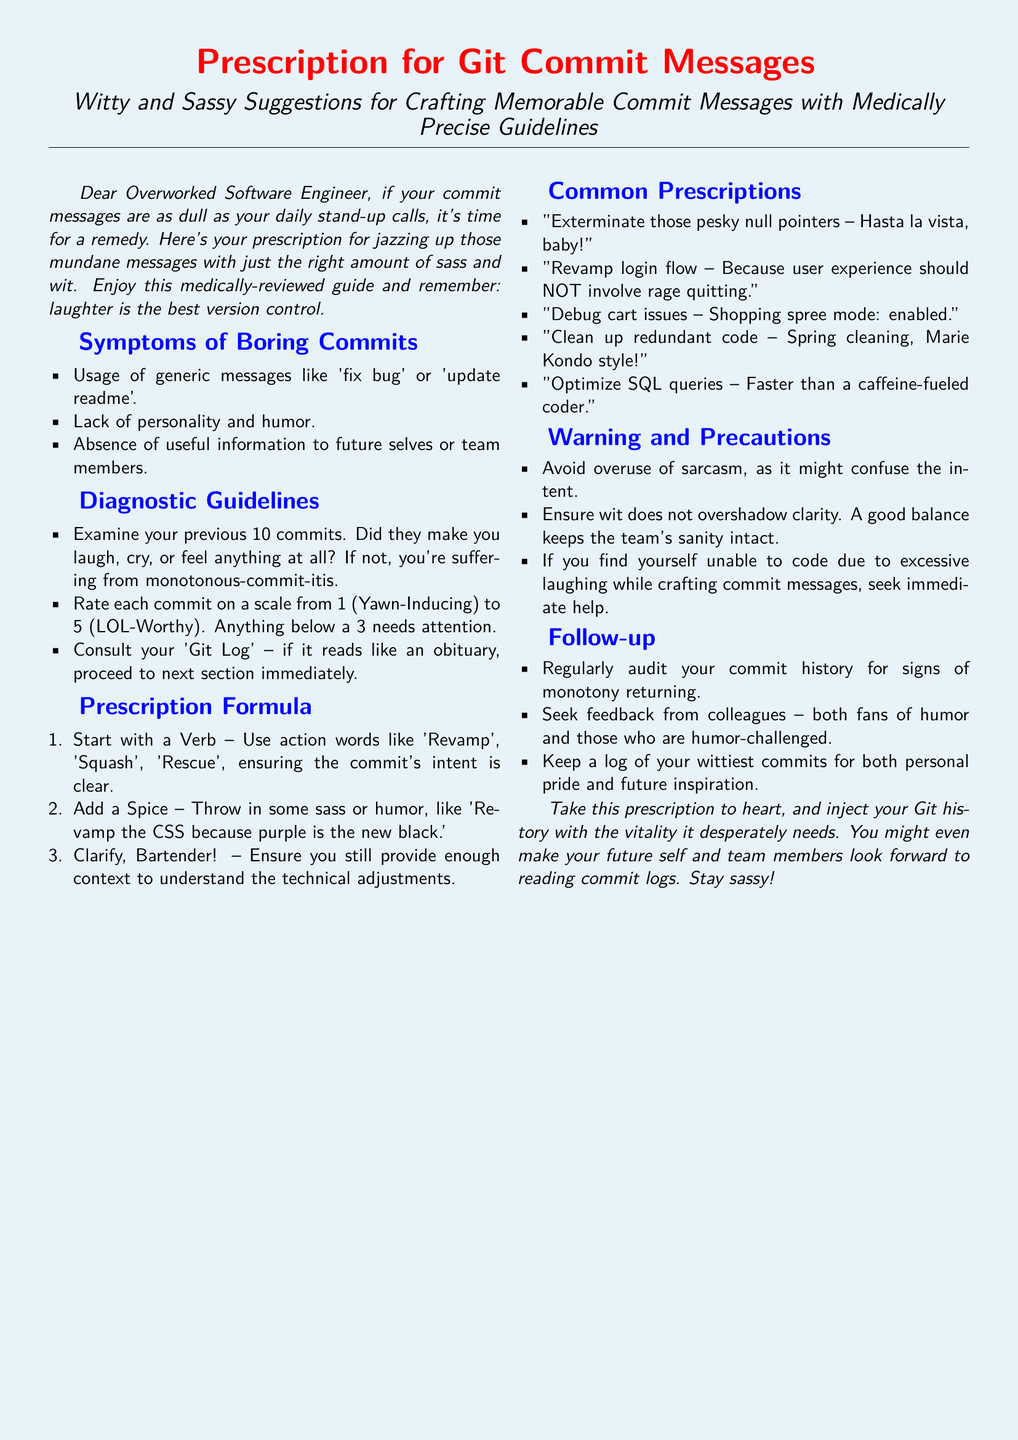What is the title of the document? The title of the document is explicitly stated at the beginning as "Prescription for Git Commit Messages."
Answer: Prescription for Git Commit Messages What color is the page background? The document specifies the page background color as a light blue shade.
Answer: Prescription blue How many symptoms of boring commits are listed? The document lists three specific symptoms of boring commits.
Answer: 3 What is the rating scale mentioned for assessing commit messages? The rating scale mentioned is from 1 (Yawn-Inducing) to 5 (LOL-Worthy).
Answer: 1 to 5 What should be the first action word in a commit message? The document prescribes starting with a verb in the commit messages.
Answer: Verb What humorous example is given for cleaning up redundant code? The document humorously suggests "Spring cleaning, Marie Kondo style!" for cleaning code.
Answer: Spring cleaning, Marie Kondo style! What is advised to avoid in commit messages? The document cautions against overuse of sarcasm in commit messages.
Answer: Overuse of sarcasm What should you regularly audit to avoid monotony? The document advises regular audits of your commit history.
Answer: Commit history What is the follow-up action suggested after crafting commit messages? The document suggests seeking feedback from colleagues as a follow-up action.
Answer: Seek feedback from colleagues 